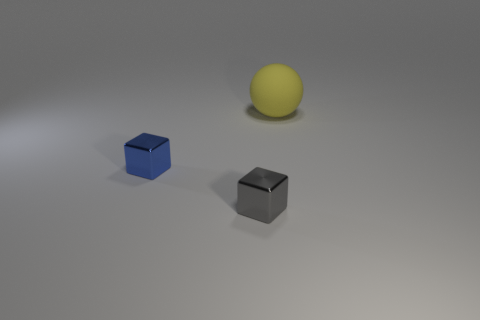Add 2 big red spheres. How many objects exist? 5 Subtract all cubes. How many objects are left? 1 Subtract all gray cubes. How many cubes are left? 1 Subtract 0 yellow cylinders. How many objects are left? 3 Subtract 1 spheres. How many spheres are left? 0 Subtract all gray balls. Subtract all yellow cubes. How many balls are left? 1 Subtract all small metal things. Subtract all gray blocks. How many objects are left? 0 Add 1 gray shiny cubes. How many gray shiny cubes are left? 2 Add 3 big blue matte blocks. How many big blue matte blocks exist? 3 